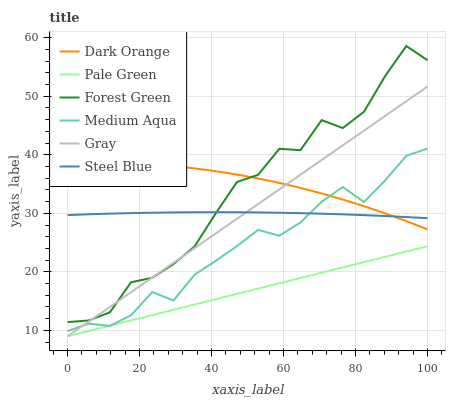Does Gray have the minimum area under the curve?
Answer yes or no. No. Does Gray have the maximum area under the curve?
Answer yes or no. No. Is Gray the smoothest?
Answer yes or no. No. Is Gray the roughest?
Answer yes or no. No. Does Steel Blue have the lowest value?
Answer yes or no. No. Does Gray have the highest value?
Answer yes or no. No. Is Pale Green less than Steel Blue?
Answer yes or no. Yes. Is Dark Orange greater than Pale Green?
Answer yes or no. Yes. Does Pale Green intersect Steel Blue?
Answer yes or no. No. 